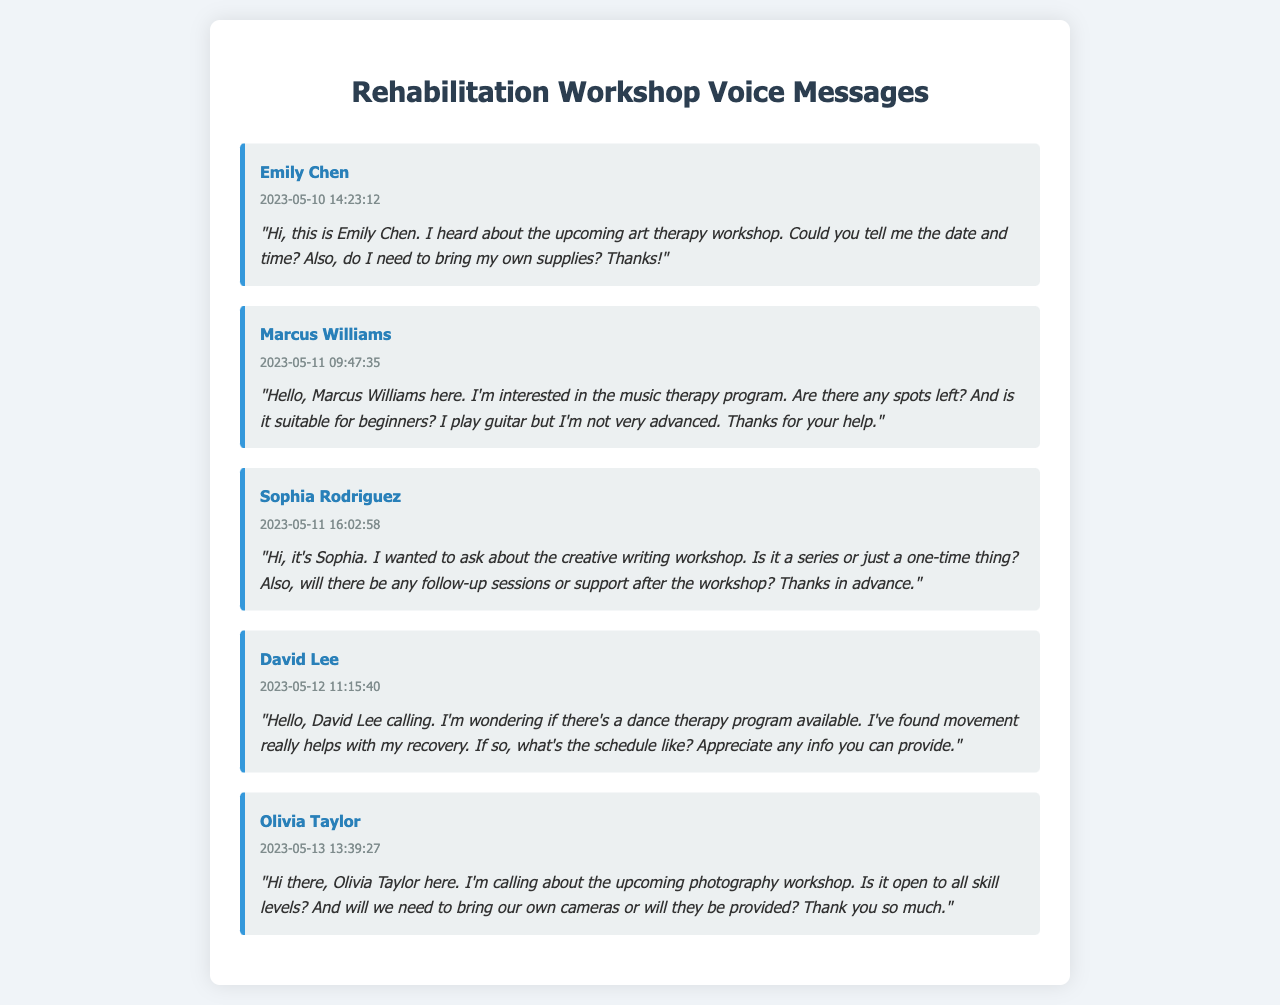What is the name of the artist who called about the art therapy workshop? Emily Chen is the artist mentioned in the document who inquired about the art therapy workshop.
Answer: Emily Chen What date did Marcus Williams leave his message? The timestamp indicates that Marcus Williams left his message on May 11, 2023.
Answer: 2023-05-11 Is the music therapy program suitable for beginners? Marcus Williams specifically asked if the music therapy program is suitable for beginners in his message.
Answer: Yes What type of workshop did Sophia Rodriguez inquire about? Sophia Rodriguez asked about the creative writing workshop, as indicated in her message.
Answer: Creative writing What is David Lee interested in regarding rehabilitation? David Lee is looking for information on a dance therapy program that could help with his recovery.
Answer: Dance therapy How did Olivia Taylor want to know about the photography workshop? Olivia Taylor wanted to find out if the photography workshop is open to all skill levels and if cameras are provided.
Answer: Open to all skill levels What is the time mentioned in Emily Chen's message? Emily Chen left her message at 14:23:12, which is the time noted in her transcript.
Answer: 14:23:12 Who needs to bring their own supplies for the art therapy workshop? Emily Chen asked if she needs to bring her own supplies for the workshop.
Answer: Yes How many artists left voice messages according to the document? The document contains messages from five different artists, indicating their inquiries about various workshops.
Answer: Five 